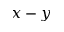<formula> <loc_0><loc_0><loc_500><loc_500>x - y</formula> 